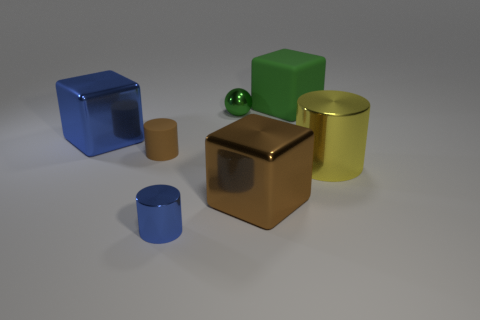Add 3 big blue things. How many objects exist? 10 Subtract all spheres. How many objects are left? 6 Add 3 big yellow shiny things. How many big yellow shiny things are left? 4 Add 6 green blocks. How many green blocks exist? 7 Subtract 1 yellow cylinders. How many objects are left? 6 Subtract all big red objects. Subtract all shiny blocks. How many objects are left? 5 